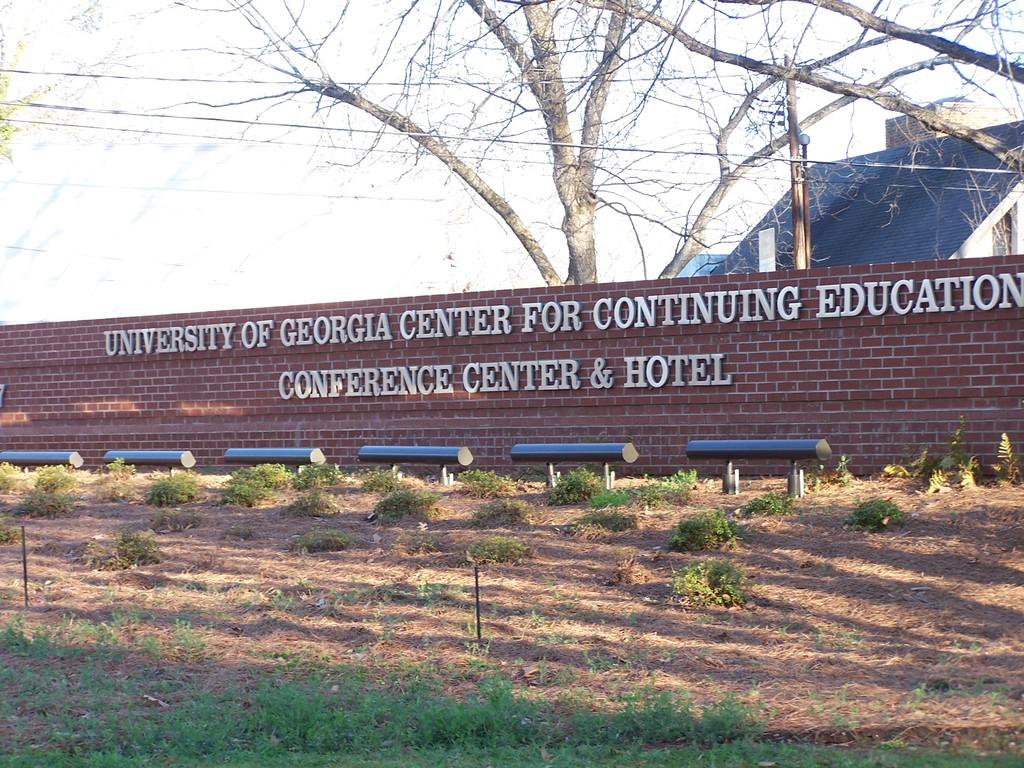What type of structure can be seen in the image? There is a house in the image. What is located near the house? There is a wall in the image. What type of vegetation is present in the image? There is a tree and grass in the image. Can you see a chess game being played on the grass in the image? There is no chess game or any indication of a game being played in the image. 